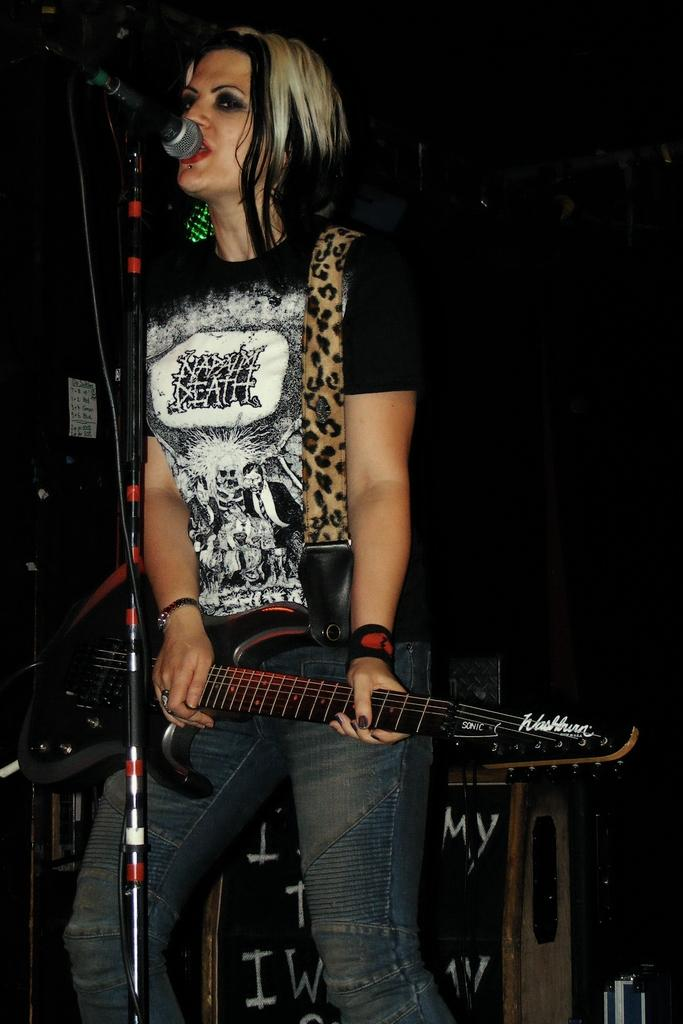Who is the main subject in the image? There is a woman in the image. Where is the woman positioned in the image? The woman is standing in the center. What is the woman holding in the image? The woman is holding a guitar. What is the woman doing in the image? The woman is singing on a microphone. How many clovers can be seen growing around the woman in the image? There are no clovers visible in the image. What type of competition is the woman participating in while holding the guitar? There is no indication of a competition in the image; the woman is simply singing on a microphone. 